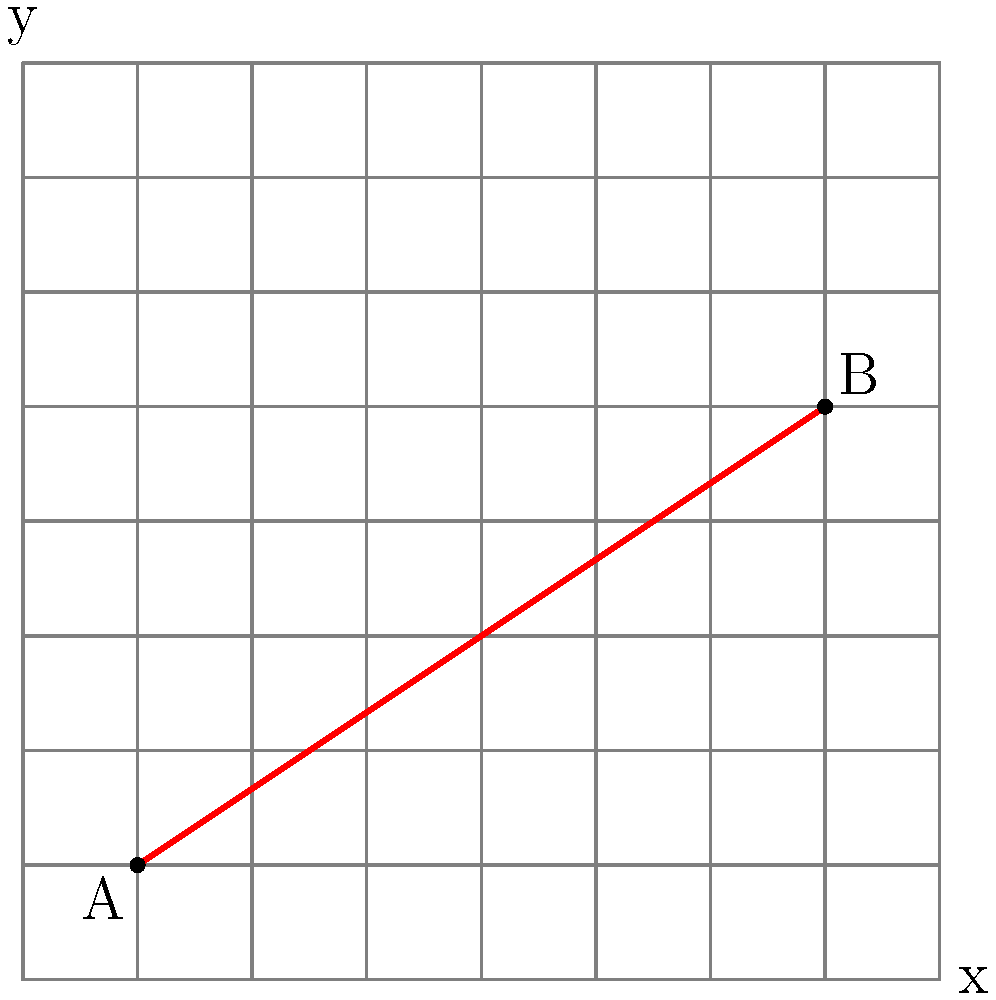In the depths of your brooding dungeon, you've discovered two ancient rune stones at locations A(1,1) and B(7,5) on your grid map. As the Dungeon Master, you need to determine the equation of the line passing through these two mystical points. What is the slope-intercept form $(y = mx + b)$ of this line of power? Let's embark on this dark quest to find the equation, step by step:

1) First, we need to calculate the slope $(m)$ of the line. The slope formula is:

   $m = \frac{y_2 - y_1}{x_2 - x_1}$

   Where $(x_1, y_1)$ is point A and $(x_2, y_2)$ is point B.

2) Plugging in our coordinates:

   $m = \frac{5 - 1}{7 - 1} = \frac{4}{6} = \frac{2}{3}$

3) Now that we have the slope, we can use the point-slope form of a line:

   $y - y_1 = m(x - x_1)$

4) Let's use point A(1,1). Substituting our values:

   $y - 1 = \frac{2}{3}(x - 1)$

5) Distribute the $\frac{2}{3}$:

   $y - 1 = \frac{2}{3}x - \frac{2}{3}$

6) Add 1 to both sides to isolate $y$:

   $y = \frac{2}{3}x - \frac{2}{3} + 1$

7) Simplify:

   $y = \frac{2}{3}x + \frac{1}{3}$

Thus, we have uncovered the mystical equation of the line in slope-intercept form.
Answer: $y = \frac{2}{3}x + \frac{1}{3}$ 